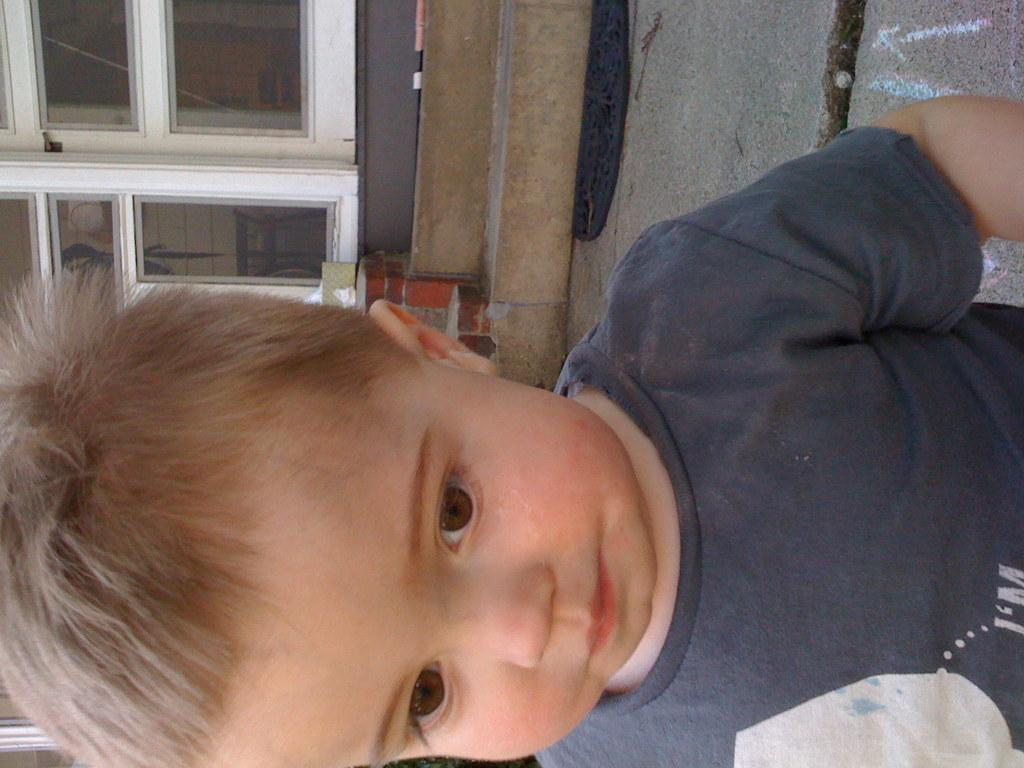Who is the main subject in the image? There is a boy in the image. What can be seen at the top of the image? There is a door and stairs at the top of the image. What is on the floor in the image? There is a floor mat on the floor in the image. What type of quartz can be seen in the boy's throat in the image? There is no quartz or any reference to the boy's throat in the image. 